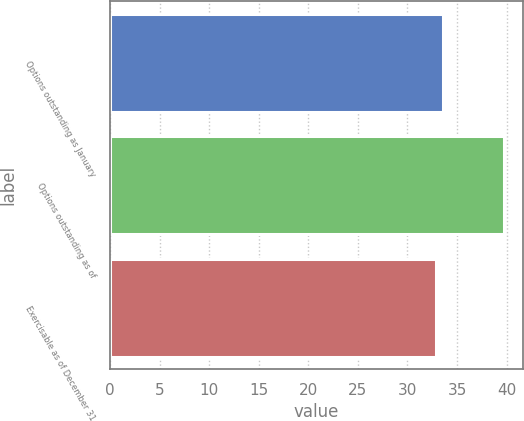Convert chart. <chart><loc_0><loc_0><loc_500><loc_500><bar_chart><fcel>Options outstanding as January<fcel>Options outstanding as of<fcel>Exercisable as of December 31<nl><fcel>33.6<fcel>39.7<fcel>32.92<nl></chart> 